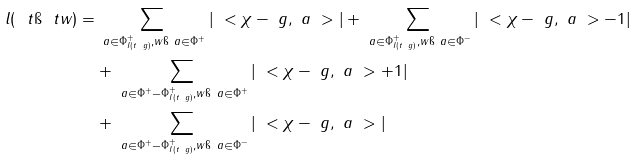Convert formula to latex. <formula><loc_0><loc_0><loc_500><loc_500>l ( \ t \i \ t w ) = & \sum _ { \ a \in \Phi ^ { + } _ { I ( t ^ { \ } g ) } , w \i \ a \in \Phi ^ { + } } | \ < \chi - \ g , \ a \ > | + \sum _ { \ a \in \Phi ^ { + } _ { I ( t ^ { \ } g ) } , w \i \ a \in \Phi ^ { - } } | \ < \chi - \ g , \ a \ > - 1 | \\ & + \sum _ { \ a \in \Phi ^ { + } - \Phi ^ { + } _ { I ( t ^ { \ } g ) } , w \i \ a \in \Phi ^ { + } } | \ < \chi - \ g , \ a \ > + 1 | \\ & + \sum _ { \ a \in \Phi ^ { + } - \Phi ^ { + } _ { I ( t ^ { \ } g ) } , w \i \ a \in \Phi ^ { - } } | \ < \chi - \ g , \ a \ > |</formula> 